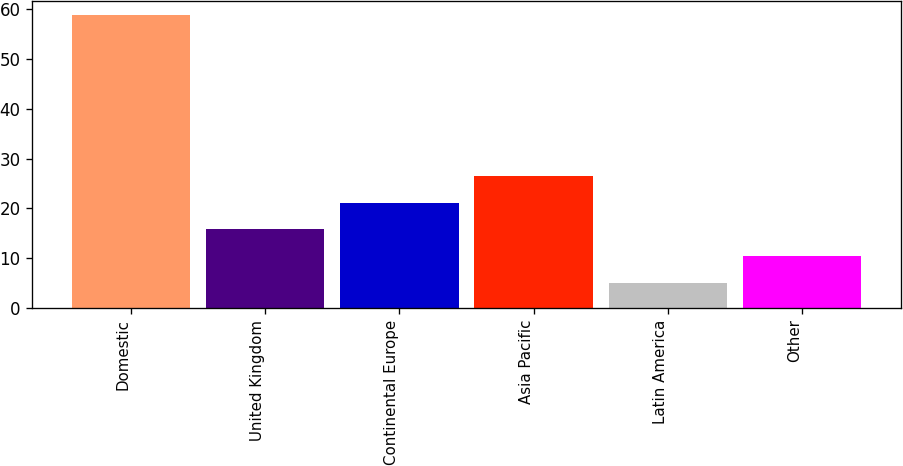Convert chart to OTSL. <chart><loc_0><loc_0><loc_500><loc_500><bar_chart><fcel>Domestic<fcel>United Kingdom<fcel>Continental Europe<fcel>Asia Pacific<fcel>Latin America<fcel>Other<nl><fcel>58.8<fcel>15.76<fcel>21.14<fcel>26.52<fcel>5<fcel>10.38<nl></chart> 